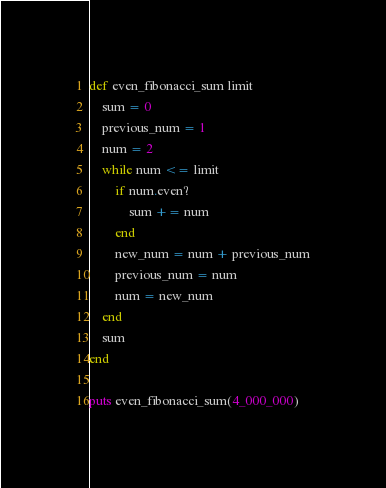<code> <loc_0><loc_0><loc_500><loc_500><_Ruby_>def even_fibonacci_sum limit
    sum = 0
    previous_num = 1
    num = 2
    while num <= limit
        if num.even?
            sum += num
        end
        new_num = num + previous_num
        previous_num = num
        num = new_num
    end
    sum
end

puts even_fibonacci_sum(4_000_000)</code> 